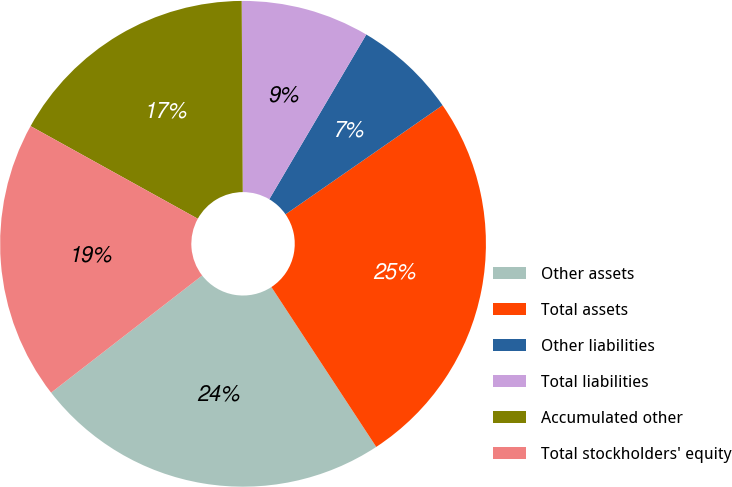Convert chart to OTSL. <chart><loc_0><loc_0><loc_500><loc_500><pie_chart><fcel>Other assets<fcel>Total assets<fcel>Other liabilities<fcel>Total liabilities<fcel>Accumulated other<fcel>Total stockholders' equity<nl><fcel>23.74%<fcel>25.42%<fcel>6.87%<fcel>8.56%<fcel>16.86%<fcel>18.55%<nl></chart> 